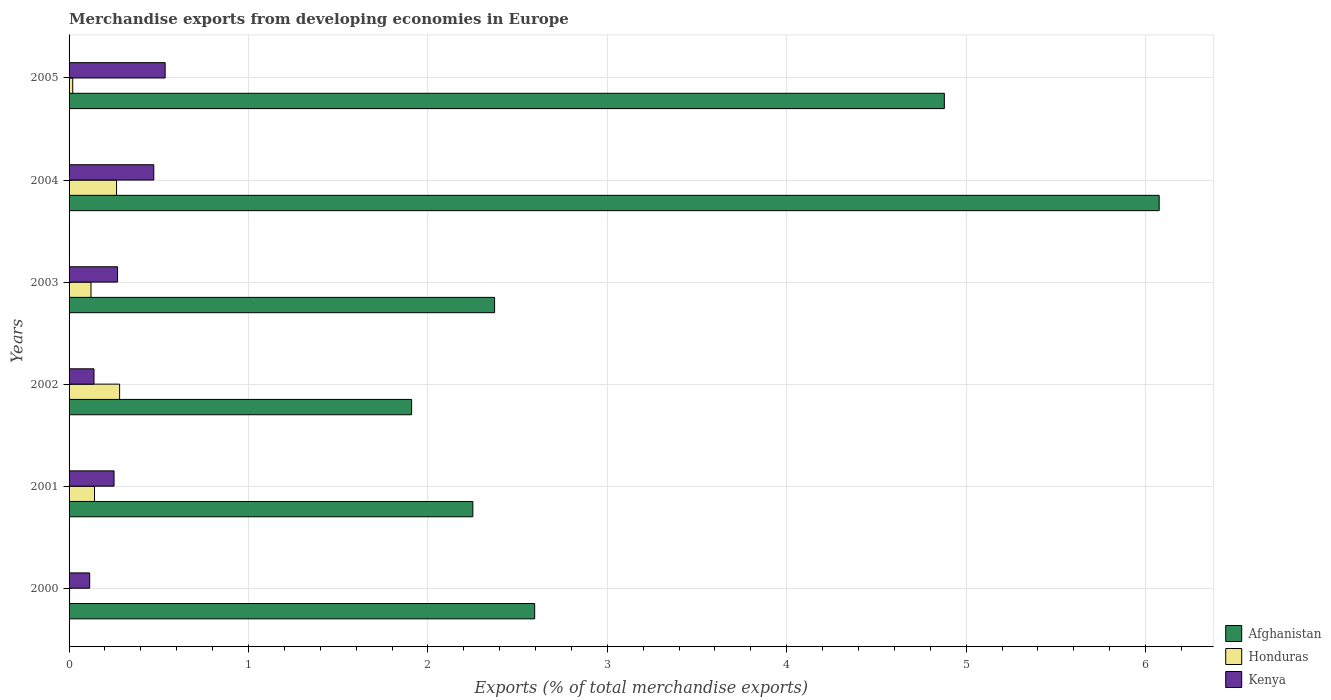How many different coloured bars are there?
Keep it short and to the point. 3. How many groups of bars are there?
Provide a succinct answer. 6. Are the number of bars per tick equal to the number of legend labels?
Keep it short and to the point. Yes. How many bars are there on the 4th tick from the top?
Offer a very short reply. 3. What is the label of the 4th group of bars from the top?
Offer a very short reply. 2002. In how many cases, is the number of bars for a given year not equal to the number of legend labels?
Your response must be concise. 0. What is the percentage of total merchandise exports in Kenya in 2001?
Give a very brief answer. 0.25. Across all years, what is the maximum percentage of total merchandise exports in Afghanistan?
Ensure brevity in your answer.  6.08. Across all years, what is the minimum percentage of total merchandise exports in Honduras?
Provide a short and direct response. 0. In which year was the percentage of total merchandise exports in Afghanistan minimum?
Your response must be concise. 2002. What is the total percentage of total merchandise exports in Afghanistan in the graph?
Your answer should be compact. 20.08. What is the difference between the percentage of total merchandise exports in Honduras in 2002 and that in 2004?
Make the answer very short. 0.02. What is the difference between the percentage of total merchandise exports in Kenya in 2001 and the percentage of total merchandise exports in Honduras in 2003?
Your response must be concise. 0.13. What is the average percentage of total merchandise exports in Kenya per year?
Your answer should be compact. 0.3. In the year 2002, what is the difference between the percentage of total merchandise exports in Honduras and percentage of total merchandise exports in Kenya?
Keep it short and to the point. 0.14. In how many years, is the percentage of total merchandise exports in Honduras greater than 3.4 %?
Provide a succinct answer. 0. What is the ratio of the percentage of total merchandise exports in Kenya in 2000 to that in 2001?
Your answer should be compact. 0.46. Is the percentage of total merchandise exports in Honduras in 2001 less than that in 2003?
Your answer should be very brief. No. Is the difference between the percentage of total merchandise exports in Honduras in 2000 and 2005 greater than the difference between the percentage of total merchandise exports in Kenya in 2000 and 2005?
Give a very brief answer. Yes. What is the difference between the highest and the second highest percentage of total merchandise exports in Afghanistan?
Ensure brevity in your answer.  1.2. What is the difference between the highest and the lowest percentage of total merchandise exports in Honduras?
Keep it short and to the point. 0.28. Is the sum of the percentage of total merchandise exports in Kenya in 2000 and 2005 greater than the maximum percentage of total merchandise exports in Afghanistan across all years?
Give a very brief answer. No. What does the 2nd bar from the top in 2001 represents?
Offer a very short reply. Honduras. What does the 3rd bar from the bottom in 2003 represents?
Provide a succinct answer. Kenya. Is it the case that in every year, the sum of the percentage of total merchandise exports in Honduras and percentage of total merchandise exports in Kenya is greater than the percentage of total merchandise exports in Afghanistan?
Provide a short and direct response. No. Are the values on the major ticks of X-axis written in scientific E-notation?
Your answer should be very brief. No. Does the graph contain any zero values?
Make the answer very short. No. Does the graph contain grids?
Keep it short and to the point. Yes. Where does the legend appear in the graph?
Provide a short and direct response. Bottom right. How many legend labels are there?
Give a very brief answer. 3. What is the title of the graph?
Ensure brevity in your answer.  Merchandise exports from developing economies in Europe. What is the label or title of the X-axis?
Ensure brevity in your answer.  Exports (% of total merchandise exports). What is the label or title of the Y-axis?
Your response must be concise. Years. What is the Exports (% of total merchandise exports) of Afghanistan in 2000?
Provide a succinct answer. 2.6. What is the Exports (% of total merchandise exports) of Honduras in 2000?
Offer a terse response. 0. What is the Exports (% of total merchandise exports) of Kenya in 2000?
Give a very brief answer. 0.11. What is the Exports (% of total merchandise exports) of Afghanistan in 2001?
Your answer should be very brief. 2.25. What is the Exports (% of total merchandise exports) in Honduras in 2001?
Your answer should be compact. 0.14. What is the Exports (% of total merchandise exports) in Kenya in 2001?
Your answer should be compact. 0.25. What is the Exports (% of total merchandise exports) of Afghanistan in 2002?
Your response must be concise. 1.91. What is the Exports (% of total merchandise exports) of Honduras in 2002?
Your answer should be very brief. 0.28. What is the Exports (% of total merchandise exports) in Kenya in 2002?
Ensure brevity in your answer.  0.14. What is the Exports (% of total merchandise exports) of Afghanistan in 2003?
Give a very brief answer. 2.37. What is the Exports (% of total merchandise exports) in Honduras in 2003?
Offer a terse response. 0.12. What is the Exports (% of total merchandise exports) in Kenya in 2003?
Keep it short and to the point. 0.27. What is the Exports (% of total merchandise exports) in Afghanistan in 2004?
Your response must be concise. 6.08. What is the Exports (% of total merchandise exports) of Honduras in 2004?
Give a very brief answer. 0.26. What is the Exports (% of total merchandise exports) in Kenya in 2004?
Your response must be concise. 0.47. What is the Exports (% of total merchandise exports) of Afghanistan in 2005?
Offer a very short reply. 4.88. What is the Exports (% of total merchandise exports) in Honduras in 2005?
Offer a very short reply. 0.02. What is the Exports (% of total merchandise exports) in Kenya in 2005?
Ensure brevity in your answer.  0.54. Across all years, what is the maximum Exports (% of total merchandise exports) in Afghanistan?
Offer a terse response. 6.08. Across all years, what is the maximum Exports (% of total merchandise exports) of Honduras?
Your answer should be very brief. 0.28. Across all years, what is the maximum Exports (% of total merchandise exports) in Kenya?
Your answer should be very brief. 0.54. Across all years, what is the minimum Exports (% of total merchandise exports) in Afghanistan?
Your answer should be compact. 1.91. Across all years, what is the minimum Exports (% of total merchandise exports) in Honduras?
Provide a short and direct response. 0. Across all years, what is the minimum Exports (% of total merchandise exports) in Kenya?
Your answer should be very brief. 0.11. What is the total Exports (% of total merchandise exports) in Afghanistan in the graph?
Make the answer very short. 20.08. What is the total Exports (% of total merchandise exports) in Honduras in the graph?
Keep it short and to the point. 0.83. What is the total Exports (% of total merchandise exports) of Kenya in the graph?
Provide a succinct answer. 1.78. What is the difference between the Exports (% of total merchandise exports) in Afghanistan in 2000 and that in 2001?
Provide a succinct answer. 0.34. What is the difference between the Exports (% of total merchandise exports) of Honduras in 2000 and that in 2001?
Your response must be concise. -0.14. What is the difference between the Exports (% of total merchandise exports) of Kenya in 2000 and that in 2001?
Keep it short and to the point. -0.14. What is the difference between the Exports (% of total merchandise exports) in Afghanistan in 2000 and that in 2002?
Provide a short and direct response. 0.69. What is the difference between the Exports (% of total merchandise exports) in Honduras in 2000 and that in 2002?
Offer a terse response. -0.28. What is the difference between the Exports (% of total merchandise exports) of Kenya in 2000 and that in 2002?
Offer a terse response. -0.02. What is the difference between the Exports (% of total merchandise exports) in Afghanistan in 2000 and that in 2003?
Keep it short and to the point. 0.22. What is the difference between the Exports (% of total merchandise exports) in Honduras in 2000 and that in 2003?
Keep it short and to the point. -0.12. What is the difference between the Exports (% of total merchandise exports) in Kenya in 2000 and that in 2003?
Your response must be concise. -0.16. What is the difference between the Exports (% of total merchandise exports) of Afghanistan in 2000 and that in 2004?
Provide a succinct answer. -3.48. What is the difference between the Exports (% of total merchandise exports) in Honduras in 2000 and that in 2004?
Give a very brief answer. -0.26. What is the difference between the Exports (% of total merchandise exports) of Kenya in 2000 and that in 2004?
Make the answer very short. -0.36. What is the difference between the Exports (% of total merchandise exports) in Afghanistan in 2000 and that in 2005?
Your answer should be compact. -2.28. What is the difference between the Exports (% of total merchandise exports) in Honduras in 2000 and that in 2005?
Offer a terse response. -0.02. What is the difference between the Exports (% of total merchandise exports) in Kenya in 2000 and that in 2005?
Provide a short and direct response. -0.42. What is the difference between the Exports (% of total merchandise exports) in Afghanistan in 2001 and that in 2002?
Your answer should be very brief. 0.34. What is the difference between the Exports (% of total merchandise exports) of Honduras in 2001 and that in 2002?
Ensure brevity in your answer.  -0.14. What is the difference between the Exports (% of total merchandise exports) of Kenya in 2001 and that in 2002?
Your answer should be very brief. 0.11. What is the difference between the Exports (% of total merchandise exports) of Afghanistan in 2001 and that in 2003?
Your answer should be very brief. -0.12. What is the difference between the Exports (% of total merchandise exports) in Honduras in 2001 and that in 2003?
Your answer should be very brief. 0.02. What is the difference between the Exports (% of total merchandise exports) of Kenya in 2001 and that in 2003?
Your answer should be very brief. -0.02. What is the difference between the Exports (% of total merchandise exports) of Afghanistan in 2001 and that in 2004?
Offer a very short reply. -3.83. What is the difference between the Exports (% of total merchandise exports) in Honduras in 2001 and that in 2004?
Provide a succinct answer. -0.12. What is the difference between the Exports (% of total merchandise exports) of Kenya in 2001 and that in 2004?
Your answer should be very brief. -0.22. What is the difference between the Exports (% of total merchandise exports) in Afghanistan in 2001 and that in 2005?
Provide a short and direct response. -2.63. What is the difference between the Exports (% of total merchandise exports) in Honduras in 2001 and that in 2005?
Provide a succinct answer. 0.12. What is the difference between the Exports (% of total merchandise exports) in Kenya in 2001 and that in 2005?
Give a very brief answer. -0.28. What is the difference between the Exports (% of total merchandise exports) of Afghanistan in 2002 and that in 2003?
Keep it short and to the point. -0.46. What is the difference between the Exports (% of total merchandise exports) in Honduras in 2002 and that in 2003?
Give a very brief answer. 0.16. What is the difference between the Exports (% of total merchandise exports) in Kenya in 2002 and that in 2003?
Your response must be concise. -0.13. What is the difference between the Exports (% of total merchandise exports) in Afghanistan in 2002 and that in 2004?
Your answer should be very brief. -4.17. What is the difference between the Exports (% of total merchandise exports) of Honduras in 2002 and that in 2004?
Offer a terse response. 0.02. What is the difference between the Exports (% of total merchandise exports) in Afghanistan in 2002 and that in 2005?
Provide a succinct answer. -2.97. What is the difference between the Exports (% of total merchandise exports) in Honduras in 2002 and that in 2005?
Your response must be concise. 0.26. What is the difference between the Exports (% of total merchandise exports) of Kenya in 2002 and that in 2005?
Offer a terse response. -0.4. What is the difference between the Exports (% of total merchandise exports) in Afghanistan in 2003 and that in 2004?
Offer a terse response. -3.7. What is the difference between the Exports (% of total merchandise exports) of Honduras in 2003 and that in 2004?
Your answer should be very brief. -0.14. What is the difference between the Exports (% of total merchandise exports) of Kenya in 2003 and that in 2004?
Keep it short and to the point. -0.2. What is the difference between the Exports (% of total merchandise exports) in Afghanistan in 2003 and that in 2005?
Provide a short and direct response. -2.51. What is the difference between the Exports (% of total merchandise exports) of Honduras in 2003 and that in 2005?
Ensure brevity in your answer.  0.1. What is the difference between the Exports (% of total merchandise exports) in Kenya in 2003 and that in 2005?
Make the answer very short. -0.27. What is the difference between the Exports (% of total merchandise exports) in Afghanistan in 2004 and that in 2005?
Your answer should be compact. 1.2. What is the difference between the Exports (% of total merchandise exports) in Honduras in 2004 and that in 2005?
Ensure brevity in your answer.  0.24. What is the difference between the Exports (% of total merchandise exports) of Kenya in 2004 and that in 2005?
Your answer should be very brief. -0.06. What is the difference between the Exports (% of total merchandise exports) of Afghanistan in 2000 and the Exports (% of total merchandise exports) of Honduras in 2001?
Your answer should be compact. 2.45. What is the difference between the Exports (% of total merchandise exports) in Afghanistan in 2000 and the Exports (% of total merchandise exports) in Kenya in 2001?
Your response must be concise. 2.34. What is the difference between the Exports (% of total merchandise exports) in Honduras in 2000 and the Exports (% of total merchandise exports) in Kenya in 2001?
Your answer should be very brief. -0.25. What is the difference between the Exports (% of total merchandise exports) of Afghanistan in 2000 and the Exports (% of total merchandise exports) of Honduras in 2002?
Give a very brief answer. 2.31. What is the difference between the Exports (% of total merchandise exports) of Afghanistan in 2000 and the Exports (% of total merchandise exports) of Kenya in 2002?
Give a very brief answer. 2.46. What is the difference between the Exports (% of total merchandise exports) of Honduras in 2000 and the Exports (% of total merchandise exports) of Kenya in 2002?
Offer a terse response. -0.14. What is the difference between the Exports (% of total merchandise exports) of Afghanistan in 2000 and the Exports (% of total merchandise exports) of Honduras in 2003?
Keep it short and to the point. 2.47. What is the difference between the Exports (% of total merchandise exports) in Afghanistan in 2000 and the Exports (% of total merchandise exports) in Kenya in 2003?
Offer a very short reply. 2.32. What is the difference between the Exports (% of total merchandise exports) of Honduras in 2000 and the Exports (% of total merchandise exports) of Kenya in 2003?
Keep it short and to the point. -0.27. What is the difference between the Exports (% of total merchandise exports) in Afghanistan in 2000 and the Exports (% of total merchandise exports) in Honduras in 2004?
Keep it short and to the point. 2.33. What is the difference between the Exports (% of total merchandise exports) in Afghanistan in 2000 and the Exports (% of total merchandise exports) in Kenya in 2004?
Ensure brevity in your answer.  2.12. What is the difference between the Exports (% of total merchandise exports) in Honduras in 2000 and the Exports (% of total merchandise exports) in Kenya in 2004?
Make the answer very short. -0.47. What is the difference between the Exports (% of total merchandise exports) of Afghanistan in 2000 and the Exports (% of total merchandise exports) of Honduras in 2005?
Your answer should be compact. 2.57. What is the difference between the Exports (% of total merchandise exports) of Afghanistan in 2000 and the Exports (% of total merchandise exports) of Kenya in 2005?
Your answer should be very brief. 2.06. What is the difference between the Exports (% of total merchandise exports) in Honduras in 2000 and the Exports (% of total merchandise exports) in Kenya in 2005?
Your answer should be very brief. -0.53. What is the difference between the Exports (% of total merchandise exports) of Afghanistan in 2001 and the Exports (% of total merchandise exports) of Honduras in 2002?
Make the answer very short. 1.97. What is the difference between the Exports (% of total merchandise exports) in Afghanistan in 2001 and the Exports (% of total merchandise exports) in Kenya in 2002?
Ensure brevity in your answer.  2.11. What is the difference between the Exports (% of total merchandise exports) in Honduras in 2001 and the Exports (% of total merchandise exports) in Kenya in 2002?
Provide a short and direct response. 0. What is the difference between the Exports (% of total merchandise exports) in Afghanistan in 2001 and the Exports (% of total merchandise exports) in Honduras in 2003?
Your answer should be very brief. 2.13. What is the difference between the Exports (% of total merchandise exports) in Afghanistan in 2001 and the Exports (% of total merchandise exports) in Kenya in 2003?
Your response must be concise. 1.98. What is the difference between the Exports (% of total merchandise exports) in Honduras in 2001 and the Exports (% of total merchandise exports) in Kenya in 2003?
Give a very brief answer. -0.13. What is the difference between the Exports (% of total merchandise exports) in Afghanistan in 2001 and the Exports (% of total merchandise exports) in Honduras in 2004?
Make the answer very short. 1.99. What is the difference between the Exports (% of total merchandise exports) of Afghanistan in 2001 and the Exports (% of total merchandise exports) of Kenya in 2004?
Provide a short and direct response. 1.78. What is the difference between the Exports (% of total merchandise exports) in Honduras in 2001 and the Exports (% of total merchandise exports) in Kenya in 2004?
Your answer should be compact. -0.33. What is the difference between the Exports (% of total merchandise exports) of Afghanistan in 2001 and the Exports (% of total merchandise exports) of Honduras in 2005?
Offer a terse response. 2.23. What is the difference between the Exports (% of total merchandise exports) of Afghanistan in 2001 and the Exports (% of total merchandise exports) of Kenya in 2005?
Provide a succinct answer. 1.72. What is the difference between the Exports (% of total merchandise exports) of Honduras in 2001 and the Exports (% of total merchandise exports) of Kenya in 2005?
Make the answer very short. -0.39. What is the difference between the Exports (% of total merchandise exports) in Afghanistan in 2002 and the Exports (% of total merchandise exports) in Honduras in 2003?
Offer a terse response. 1.79. What is the difference between the Exports (% of total merchandise exports) of Afghanistan in 2002 and the Exports (% of total merchandise exports) of Kenya in 2003?
Give a very brief answer. 1.64. What is the difference between the Exports (% of total merchandise exports) in Honduras in 2002 and the Exports (% of total merchandise exports) in Kenya in 2003?
Your answer should be compact. 0.01. What is the difference between the Exports (% of total merchandise exports) of Afghanistan in 2002 and the Exports (% of total merchandise exports) of Honduras in 2004?
Provide a short and direct response. 1.64. What is the difference between the Exports (% of total merchandise exports) of Afghanistan in 2002 and the Exports (% of total merchandise exports) of Kenya in 2004?
Provide a short and direct response. 1.44. What is the difference between the Exports (% of total merchandise exports) of Honduras in 2002 and the Exports (% of total merchandise exports) of Kenya in 2004?
Make the answer very short. -0.19. What is the difference between the Exports (% of total merchandise exports) of Afghanistan in 2002 and the Exports (% of total merchandise exports) of Honduras in 2005?
Your answer should be compact. 1.89. What is the difference between the Exports (% of total merchandise exports) in Afghanistan in 2002 and the Exports (% of total merchandise exports) in Kenya in 2005?
Make the answer very short. 1.37. What is the difference between the Exports (% of total merchandise exports) in Honduras in 2002 and the Exports (% of total merchandise exports) in Kenya in 2005?
Provide a short and direct response. -0.25. What is the difference between the Exports (% of total merchandise exports) of Afghanistan in 2003 and the Exports (% of total merchandise exports) of Honduras in 2004?
Offer a very short reply. 2.11. What is the difference between the Exports (% of total merchandise exports) of Afghanistan in 2003 and the Exports (% of total merchandise exports) of Kenya in 2004?
Give a very brief answer. 1.9. What is the difference between the Exports (% of total merchandise exports) in Honduras in 2003 and the Exports (% of total merchandise exports) in Kenya in 2004?
Make the answer very short. -0.35. What is the difference between the Exports (% of total merchandise exports) of Afghanistan in 2003 and the Exports (% of total merchandise exports) of Honduras in 2005?
Provide a short and direct response. 2.35. What is the difference between the Exports (% of total merchandise exports) of Afghanistan in 2003 and the Exports (% of total merchandise exports) of Kenya in 2005?
Your answer should be compact. 1.84. What is the difference between the Exports (% of total merchandise exports) of Honduras in 2003 and the Exports (% of total merchandise exports) of Kenya in 2005?
Your answer should be very brief. -0.41. What is the difference between the Exports (% of total merchandise exports) in Afghanistan in 2004 and the Exports (% of total merchandise exports) in Honduras in 2005?
Your answer should be compact. 6.06. What is the difference between the Exports (% of total merchandise exports) in Afghanistan in 2004 and the Exports (% of total merchandise exports) in Kenya in 2005?
Give a very brief answer. 5.54. What is the difference between the Exports (% of total merchandise exports) in Honduras in 2004 and the Exports (% of total merchandise exports) in Kenya in 2005?
Offer a very short reply. -0.27. What is the average Exports (% of total merchandise exports) in Afghanistan per year?
Your answer should be very brief. 3.35. What is the average Exports (% of total merchandise exports) of Honduras per year?
Provide a succinct answer. 0.14. What is the average Exports (% of total merchandise exports) of Kenya per year?
Provide a short and direct response. 0.3. In the year 2000, what is the difference between the Exports (% of total merchandise exports) in Afghanistan and Exports (% of total merchandise exports) in Honduras?
Keep it short and to the point. 2.59. In the year 2000, what is the difference between the Exports (% of total merchandise exports) of Afghanistan and Exports (% of total merchandise exports) of Kenya?
Make the answer very short. 2.48. In the year 2000, what is the difference between the Exports (% of total merchandise exports) in Honduras and Exports (% of total merchandise exports) in Kenya?
Give a very brief answer. -0.11. In the year 2001, what is the difference between the Exports (% of total merchandise exports) in Afghanistan and Exports (% of total merchandise exports) in Honduras?
Your answer should be very brief. 2.11. In the year 2001, what is the difference between the Exports (% of total merchandise exports) in Afghanistan and Exports (% of total merchandise exports) in Kenya?
Provide a short and direct response. 2. In the year 2001, what is the difference between the Exports (% of total merchandise exports) of Honduras and Exports (% of total merchandise exports) of Kenya?
Provide a succinct answer. -0.11. In the year 2002, what is the difference between the Exports (% of total merchandise exports) of Afghanistan and Exports (% of total merchandise exports) of Honduras?
Your answer should be compact. 1.63. In the year 2002, what is the difference between the Exports (% of total merchandise exports) in Afghanistan and Exports (% of total merchandise exports) in Kenya?
Make the answer very short. 1.77. In the year 2002, what is the difference between the Exports (% of total merchandise exports) of Honduras and Exports (% of total merchandise exports) of Kenya?
Make the answer very short. 0.14. In the year 2003, what is the difference between the Exports (% of total merchandise exports) in Afghanistan and Exports (% of total merchandise exports) in Honduras?
Your answer should be compact. 2.25. In the year 2003, what is the difference between the Exports (% of total merchandise exports) in Afghanistan and Exports (% of total merchandise exports) in Kenya?
Your answer should be very brief. 2.1. In the year 2003, what is the difference between the Exports (% of total merchandise exports) in Honduras and Exports (% of total merchandise exports) in Kenya?
Make the answer very short. -0.15. In the year 2004, what is the difference between the Exports (% of total merchandise exports) in Afghanistan and Exports (% of total merchandise exports) in Honduras?
Keep it short and to the point. 5.81. In the year 2004, what is the difference between the Exports (% of total merchandise exports) in Afghanistan and Exports (% of total merchandise exports) in Kenya?
Provide a short and direct response. 5.6. In the year 2004, what is the difference between the Exports (% of total merchandise exports) of Honduras and Exports (% of total merchandise exports) of Kenya?
Your answer should be compact. -0.21. In the year 2005, what is the difference between the Exports (% of total merchandise exports) of Afghanistan and Exports (% of total merchandise exports) of Honduras?
Provide a short and direct response. 4.86. In the year 2005, what is the difference between the Exports (% of total merchandise exports) of Afghanistan and Exports (% of total merchandise exports) of Kenya?
Keep it short and to the point. 4.34. In the year 2005, what is the difference between the Exports (% of total merchandise exports) in Honduras and Exports (% of total merchandise exports) in Kenya?
Offer a very short reply. -0.52. What is the ratio of the Exports (% of total merchandise exports) of Afghanistan in 2000 to that in 2001?
Offer a terse response. 1.15. What is the ratio of the Exports (% of total merchandise exports) in Honduras in 2000 to that in 2001?
Your answer should be very brief. 0.02. What is the ratio of the Exports (% of total merchandise exports) of Kenya in 2000 to that in 2001?
Offer a terse response. 0.46. What is the ratio of the Exports (% of total merchandise exports) of Afghanistan in 2000 to that in 2002?
Make the answer very short. 1.36. What is the ratio of the Exports (% of total merchandise exports) in Honduras in 2000 to that in 2002?
Your answer should be very brief. 0.01. What is the ratio of the Exports (% of total merchandise exports) of Kenya in 2000 to that in 2002?
Your answer should be compact. 0.83. What is the ratio of the Exports (% of total merchandise exports) of Afghanistan in 2000 to that in 2003?
Your response must be concise. 1.09. What is the ratio of the Exports (% of total merchandise exports) in Honduras in 2000 to that in 2003?
Keep it short and to the point. 0.02. What is the ratio of the Exports (% of total merchandise exports) in Kenya in 2000 to that in 2003?
Give a very brief answer. 0.43. What is the ratio of the Exports (% of total merchandise exports) in Afghanistan in 2000 to that in 2004?
Offer a very short reply. 0.43. What is the ratio of the Exports (% of total merchandise exports) of Honduras in 2000 to that in 2004?
Your answer should be very brief. 0.01. What is the ratio of the Exports (% of total merchandise exports) in Kenya in 2000 to that in 2004?
Offer a terse response. 0.24. What is the ratio of the Exports (% of total merchandise exports) of Afghanistan in 2000 to that in 2005?
Make the answer very short. 0.53. What is the ratio of the Exports (% of total merchandise exports) in Honduras in 2000 to that in 2005?
Your response must be concise. 0.14. What is the ratio of the Exports (% of total merchandise exports) in Kenya in 2000 to that in 2005?
Provide a short and direct response. 0.21. What is the ratio of the Exports (% of total merchandise exports) of Afghanistan in 2001 to that in 2002?
Provide a succinct answer. 1.18. What is the ratio of the Exports (% of total merchandise exports) in Honduras in 2001 to that in 2002?
Offer a very short reply. 0.5. What is the ratio of the Exports (% of total merchandise exports) in Kenya in 2001 to that in 2002?
Your answer should be compact. 1.8. What is the ratio of the Exports (% of total merchandise exports) in Afghanistan in 2001 to that in 2003?
Offer a very short reply. 0.95. What is the ratio of the Exports (% of total merchandise exports) of Honduras in 2001 to that in 2003?
Make the answer very short. 1.16. What is the ratio of the Exports (% of total merchandise exports) in Kenya in 2001 to that in 2003?
Provide a short and direct response. 0.93. What is the ratio of the Exports (% of total merchandise exports) in Afghanistan in 2001 to that in 2004?
Make the answer very short. 0.37. What is the ratio of the Exports (% of total merchandise exports) in Honduras in 2001 to that in 2004?
Give a very brief answer. 0.54. What is the ratio of the Exports (% of total merchandise exports) in Kenya in 2001 to that in 2004?
Provide a short and direct response. 0.53. What is the ratio of the Exports (% of total merchandise exports) of Afghanistan in 2001 to that in 2005?
Provide a succinct answer. 0.46. What is the ratio of the Exports (% of total merchandise exports) in Honduras in 2001 to that in 2005?
Provide a succinct answer. 6.95. What is the ratio of the Exports (% of total merchandise exports) of Kenya in 2001 to that in 2005?
Provide a short and direct response. 0.47. What is the ratio of the Exports (% of total merchandise exports) in Afghanistan in 2002 to that in 2003?
Provide a succinct answer. 0.81. What is the ratio of the Exports (% of total merchandise exports) of Honduras in 2002 to that in 2003?
Ensure brevity in your answer.  2.3. What is the ratio of the Exports (% of total merchandise exports) of Kenya in 2002 to that in 2003?
Provide a short and direct response. 0.51. What is the ratio of the Exports (% of total merchandise exports) in Afghanistan in 2002 to that in 2004?
Make the answer very short. 0.31. What is the ratio of the Exports (% of total merchandise exports) of Honduras in 2002 to that in 2004?
Provide a short and direct response. 1.06. What is the ratio of the Exports (% of total merchandise exports) in Kenya in 2002 to that in 2004?
Make the answer very short. 0.29. What is the ratio of the Exports (% of total merchandise exports) in Afghanistan in 2002 to that in 2005?
Your answer should be compact. 0.39. What is the ratio of the Exports (% of total merchandise exports) in Honduras in 2002 to that in 2005?
Make the answer very short. 13.8. What is the ratio of the Exports (% of total merchandise exports) of Kenya in 2002 to that in 2005?
Offer a terse response. 0.26. What is the ratio of the Exports (% of total merchandise exports) of Afghanistan in 2003 to that in 2004?
Give a very brief answer. 0.39. What is the ratio of the Exports (% of total merchandise exports) in Honduras in 2003 to that in 2004?
Offer a very short reply. 0.46. What is the ratio of the Exports (% of total merchandise exports) in Kenya in 2003 to that in 2004?
Give a very brief answer. 0.57. What is the ratio of the Exports (% of total merchandise exports) of Afghanistan in 2003 to that in 2005?
Keep it short and to the point. 0.49. What is the ratio of the Exports (% of total merchandise exports) of Honduras in 2003 to that in 2005?
Make the answer very short. 5.99. What is the ratio of the Exports (% of total merchandise exports) in Kenya in 2003 to that in 2005?
Ensure brevity in your answer.  0.5. What is the ratio of the Exports (% of total merchandise exports) in Afghanistan in 2004 to that in 2005?
Offer a terse response. 1.25. What is the ratio of the Exports (% of total merchandise exports) of Honduras in 2004 to that in 2005?
Keep it short and to the point. 12.97. What is the ratio of the Exports (% of total merchandise exports) in Kenya in 2004 to that in 2005?
Make the answer very short. 0.88. What is the difference between the highest and the second highest Exports (% of total merchandise exports) of Afghanistan?
Provide a short and direct response. 1.2. What is the difference between the highest and the second highest Exports (% of total merchandise exports) in Honduras?
Your answer should be very brief. 0.02. What is the difference between the highest and the second highest Exports (% of total merchandise exports) in Kenya?
Make the answer very short. 0.06. What is the difference between the highest and the lowest Exports (% of total merchandise exports) of Afghanistan?
Your response must be concise. 4.17. What is the difference between the highest and the lowest Exports (% of total merchandise exports) of Honduras?
Make the answer very short. 0.28. What is the difference between the highest and the lowest Exports (% of total merchandise exports) of Kenya?
Provide a short and direct response. 0.42. 